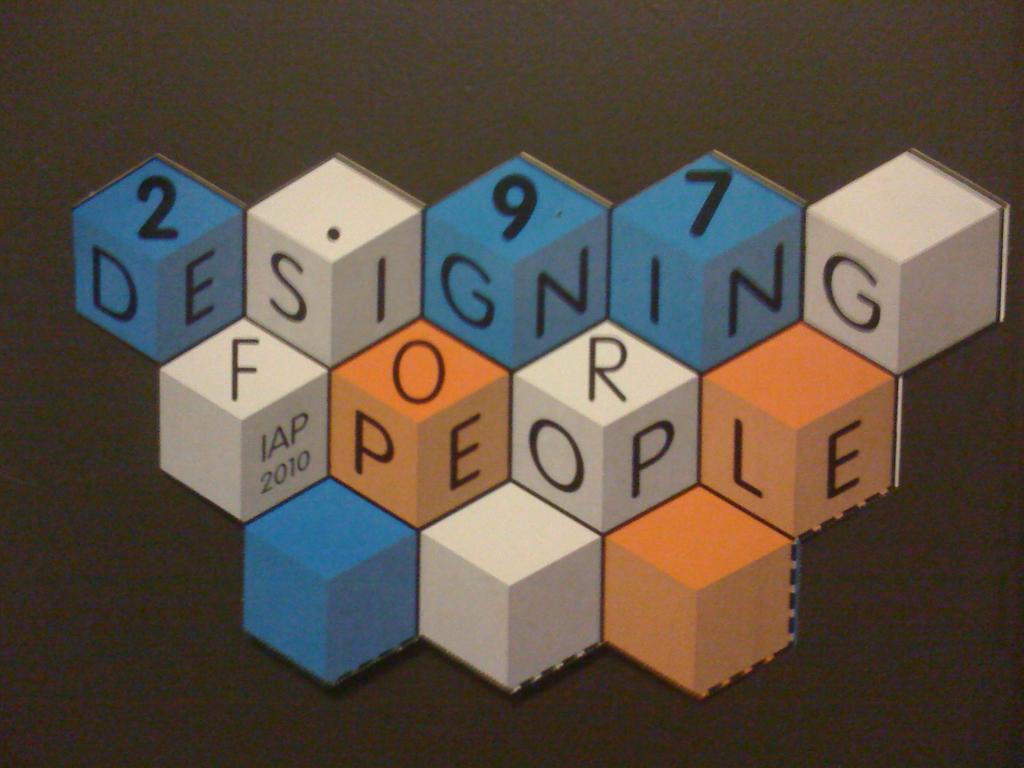What does the sign say?
Offer a very short reply. Designing for people. What numbers are shown on the blue blocks?
Give a very brief answer. 297. 